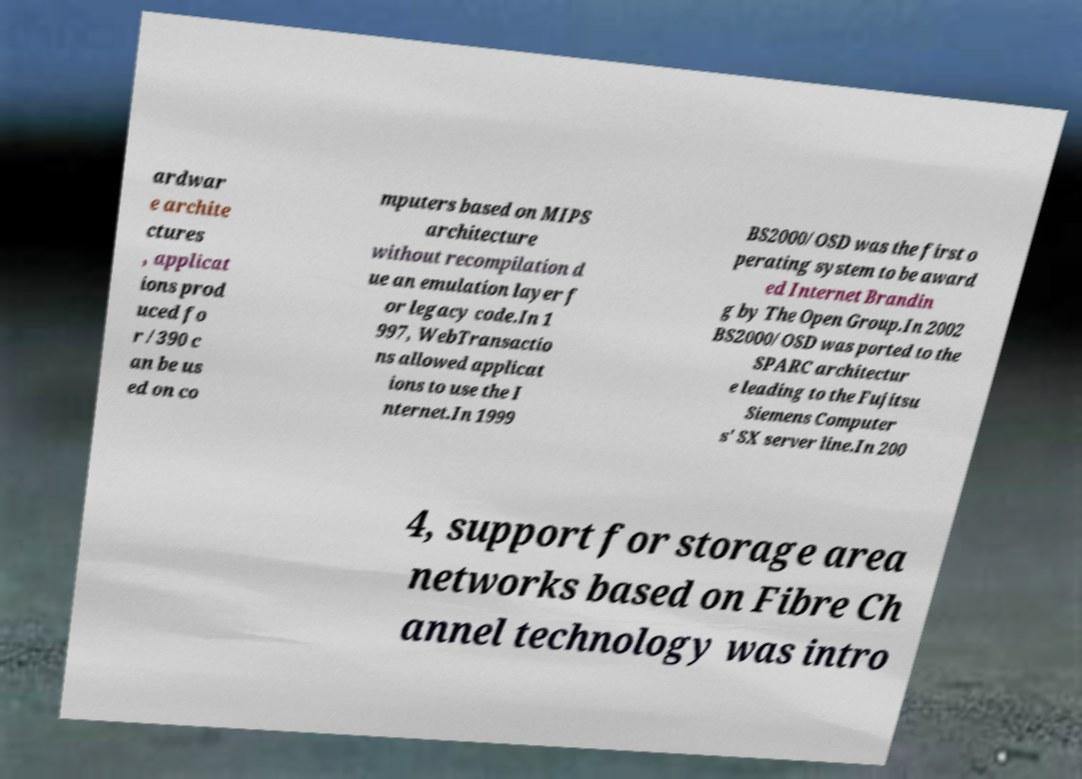Please identify and transcribe the text found in this image. ardwar e archite ctures , applicat ions prod uced fo r /390 c an be us ed on co mputers based on MIPS architecture without recompilation d ue an emulation layer f or legacy code.In 1 997, WebTransactio ns allowed applicat ions to use the I nternet.In 1999 BS2000/OSD was the first o perating system to be award ed Internet Brandin g by The Open Group.In 2002 BS2000/OSD was ported to the SPARC architectur e leading to the Fujitsu Siemens Computer s' SX server line.In 200 4, support for storage area networks based on Fibre Ch annel technology was intro 